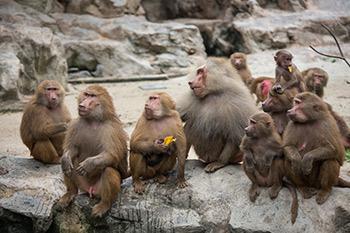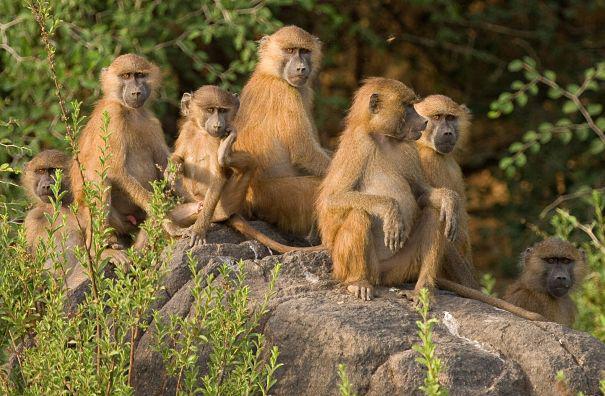The first image is the image on the left, the second image is the image on the right. Analyze the images presented: Is the assertion "There are more than seven monkeys in the image on the right." valid? Answer yes or no. No. The first image is the image on the left, the second image is the image on the right. Evaluate the accuracy of this statement regarding the images: "Baboons are mostly walking in one direction, in one image.". Is it true? Answer yes or no. No. The first image is the image on the left, the second image is the image on the right. Given the left and right images, does the statement "An image shows at least 10 monkeys on a green field." hold true? Answer yes or no. No. The first image is the image on the left, the second image is the image on the right. Analyze the images presented: Is the assertion "There are no more than half a dozen primates in the image on the left." valid? Answer yes or no. No. 